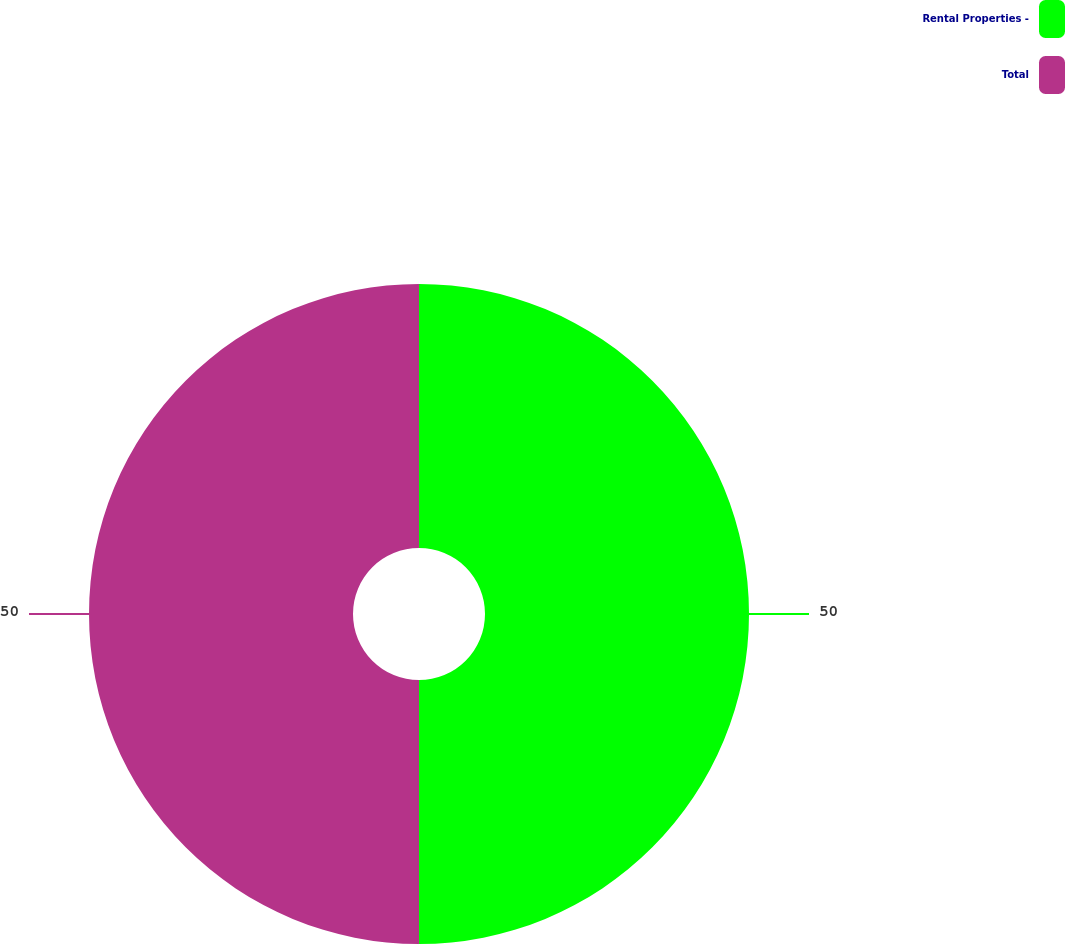<chart> <loc_0><loc_0><loc_500><loc_500><pie_chart><fcel>Rental Properties -<fcel>Total<nl><fcel>50.0%<fcel>50.0%<nl></chart> 